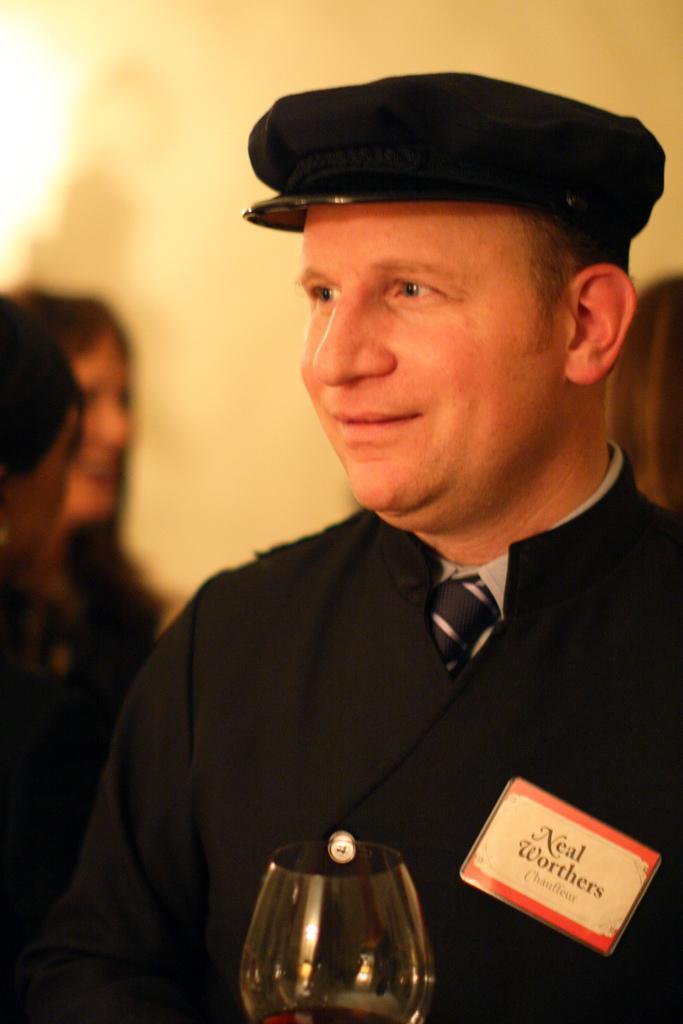Could you give a brief overview of what you see in this image? In the center of the image we can see one man standing and he is smiling, which we can see on his face. And we can see he is wearing a cap. In front of him, we can see one glass and one banner. In the background there is a wall, light, few people are standing and a few other objects. 